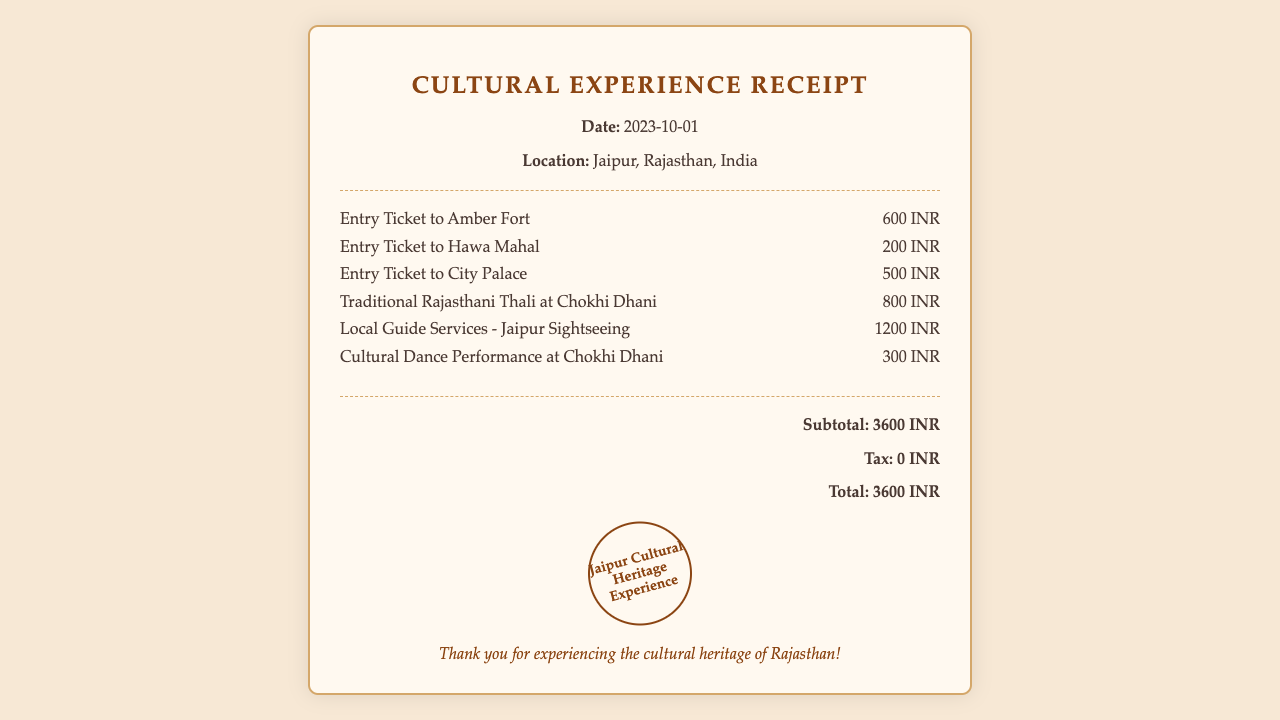what is the date of the receipt? The date is specified in the document as "2023-10-01".
Answer: 2023-10-01 what is the total amount charged? The total amount is listed at the bottom of the receipt under "Total".
Answer: 3600 INR where is this cultural experience located? The location is mentioned in the header of the receipt.
Answer: Jaipur, Rajasthan, India how much does an entry ticket to Hawa Mahal cost? The cost of the ticket is specified in the items section for Hawa Mahal.
Answer: 200 INR what service costs the most in this receipt? The item with the highest cost can be found by comparing all listed items.
Answer: Local Guide Services - Jaipur Sightseeing how many items are listed in the receipt? The number of items can be counted from the "items" section of the receipt.
Answer: 6 is there any tax applied to the total amount? The tax information is provided in the total section of the receipt.
Answer: 0 INR what is included in the subtotal calculation? The subtotal is derived from summing up all the costs of the items listed before tax.
Answer: 3600 INR what type of meal is mentioned in the receipt? The specific type of meal is provided in the item description.
Answer: Traditional Rajasthani Thali 